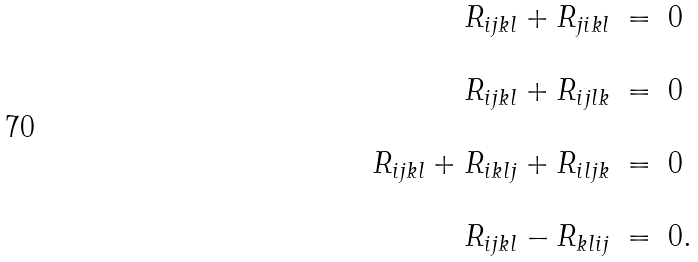<formula> <loc_0><loc_0><loc_500><loc_500>\begin{array} { r c l l } R _ { i j k l } + R _ { j i k l } & = & 0 \ & \ \\ \ & \ & \ & \ \\ R _ { i j k l } + R _ { i j l k } & = & 0 & \ \\ \ & \ & \ & \ \\ R _ { i j k l } + R _ { i k l j } + R _ { i l j k } & = & 0 & \ \\ \ & \ & \ & \ \\ R _ { i j k l } - R _ { k l i j } & = & 0 . & \ \end{array}</formula> 